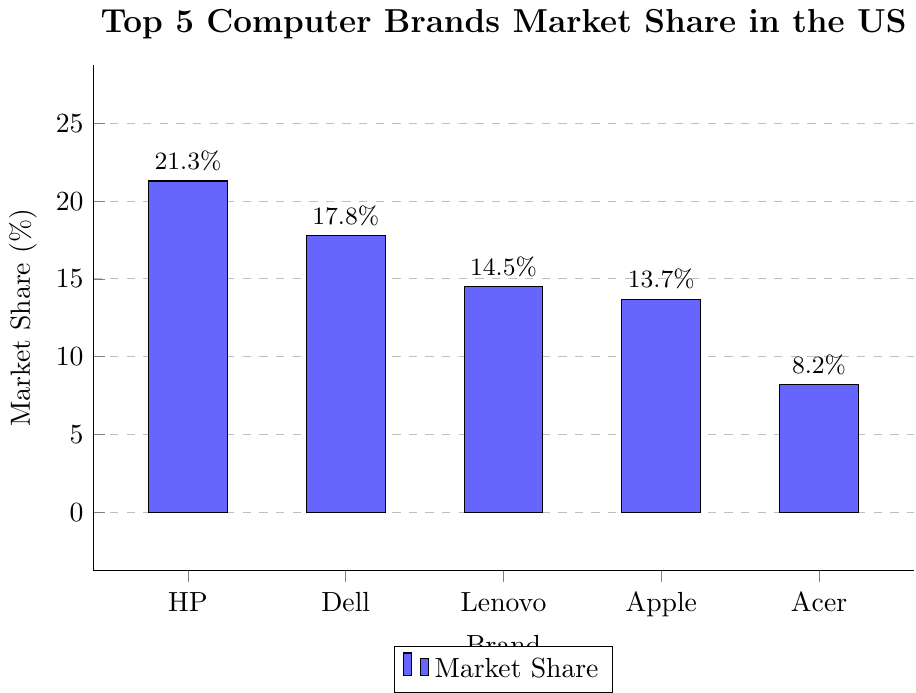What is the market share of HP? The figure shows a bar for HP with a numerical value at the top, indicating the market share.
Answer: 21.3% Which brand has the second-largest market share? By comparing the height of the bars, we see that Dell's bar is the second-highest, indicating it has the second-largest market share.
Answer: Dell What is the difference in market share between HP and Acer? The figure shows HP's market share as 21.3% and Acer's as 8.2%. Subtracting Acer's share from HP's: 21.3% - 8.2% = 13.1%.
Answer: 13.1% Which brands have a market share greater than 15%? Looking at the heights of the bars and their corresponding numbers, HP (21.3%) and Dell (17.8%) both have market shares greater than 15%.
Answer: HP, Dell How much more market share does Lenovo have compared to Acer? Lenovo's market share is 14.5%, and Acer's is 8.2%. Subtracting Acer's share from Lenovo's: 14.5% - 8.2% = 6.3%.
Answer: 6.3% What is the total market share of all five brands combined? Adding the market shares: 21.3% (HP) + 17.8% (Dell) + 14.5% (Lenovo) + 13.7% (Apple) + 8.2% (Acer) = 75.5%.
Answer: 75.5% Which brand has the smallest market share? By observing the height of the bars, Acer's bar is the shortest, indicating it has the smallest market share.
Answer: Acer Arrange the brands in descending order of their market share. Referring to the heights and values of the bars: HP (21.3%), Dell (17.8%), Lenovo (14.5%), Apple (13.7%), Acer (8.2%).
Answer: HP, Dell, Lenovo, Apple, Acer What is the average market share of the top 5 computer brands? Sum the market shares and divide by 5: (21.3% + 17.8% + 14.5% + 13.7% + 8.2%) / 5 = 75.5% / 5 = 15.1%.
Answer: 15.1% 